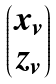<formula> <loc_0><loc_0><loc_500><loc_500>\begin{pmatrix} x _ { v } \\ z _ { v } \end{pmatrix}</formula> 